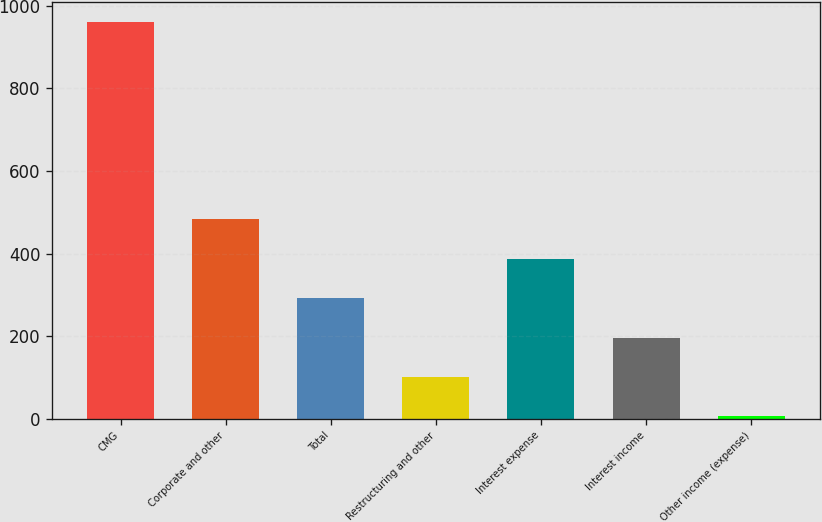Convert chart. <chart><loc_0><loc_0><loc_500><loc_500><bar_chart><fcel>CMG<fcel>Corporate and other<fcel>Total<fcel>Restructuring and other<fcel>Interest expense<fcel>Interest income<fcel>Other income (expense)<nl><fcel>960.2<fcel>482.9<fcel>291.98<fcel>101.06<fcel>387.44<fcel>196.52<fcel>5.6<nl></chart> 